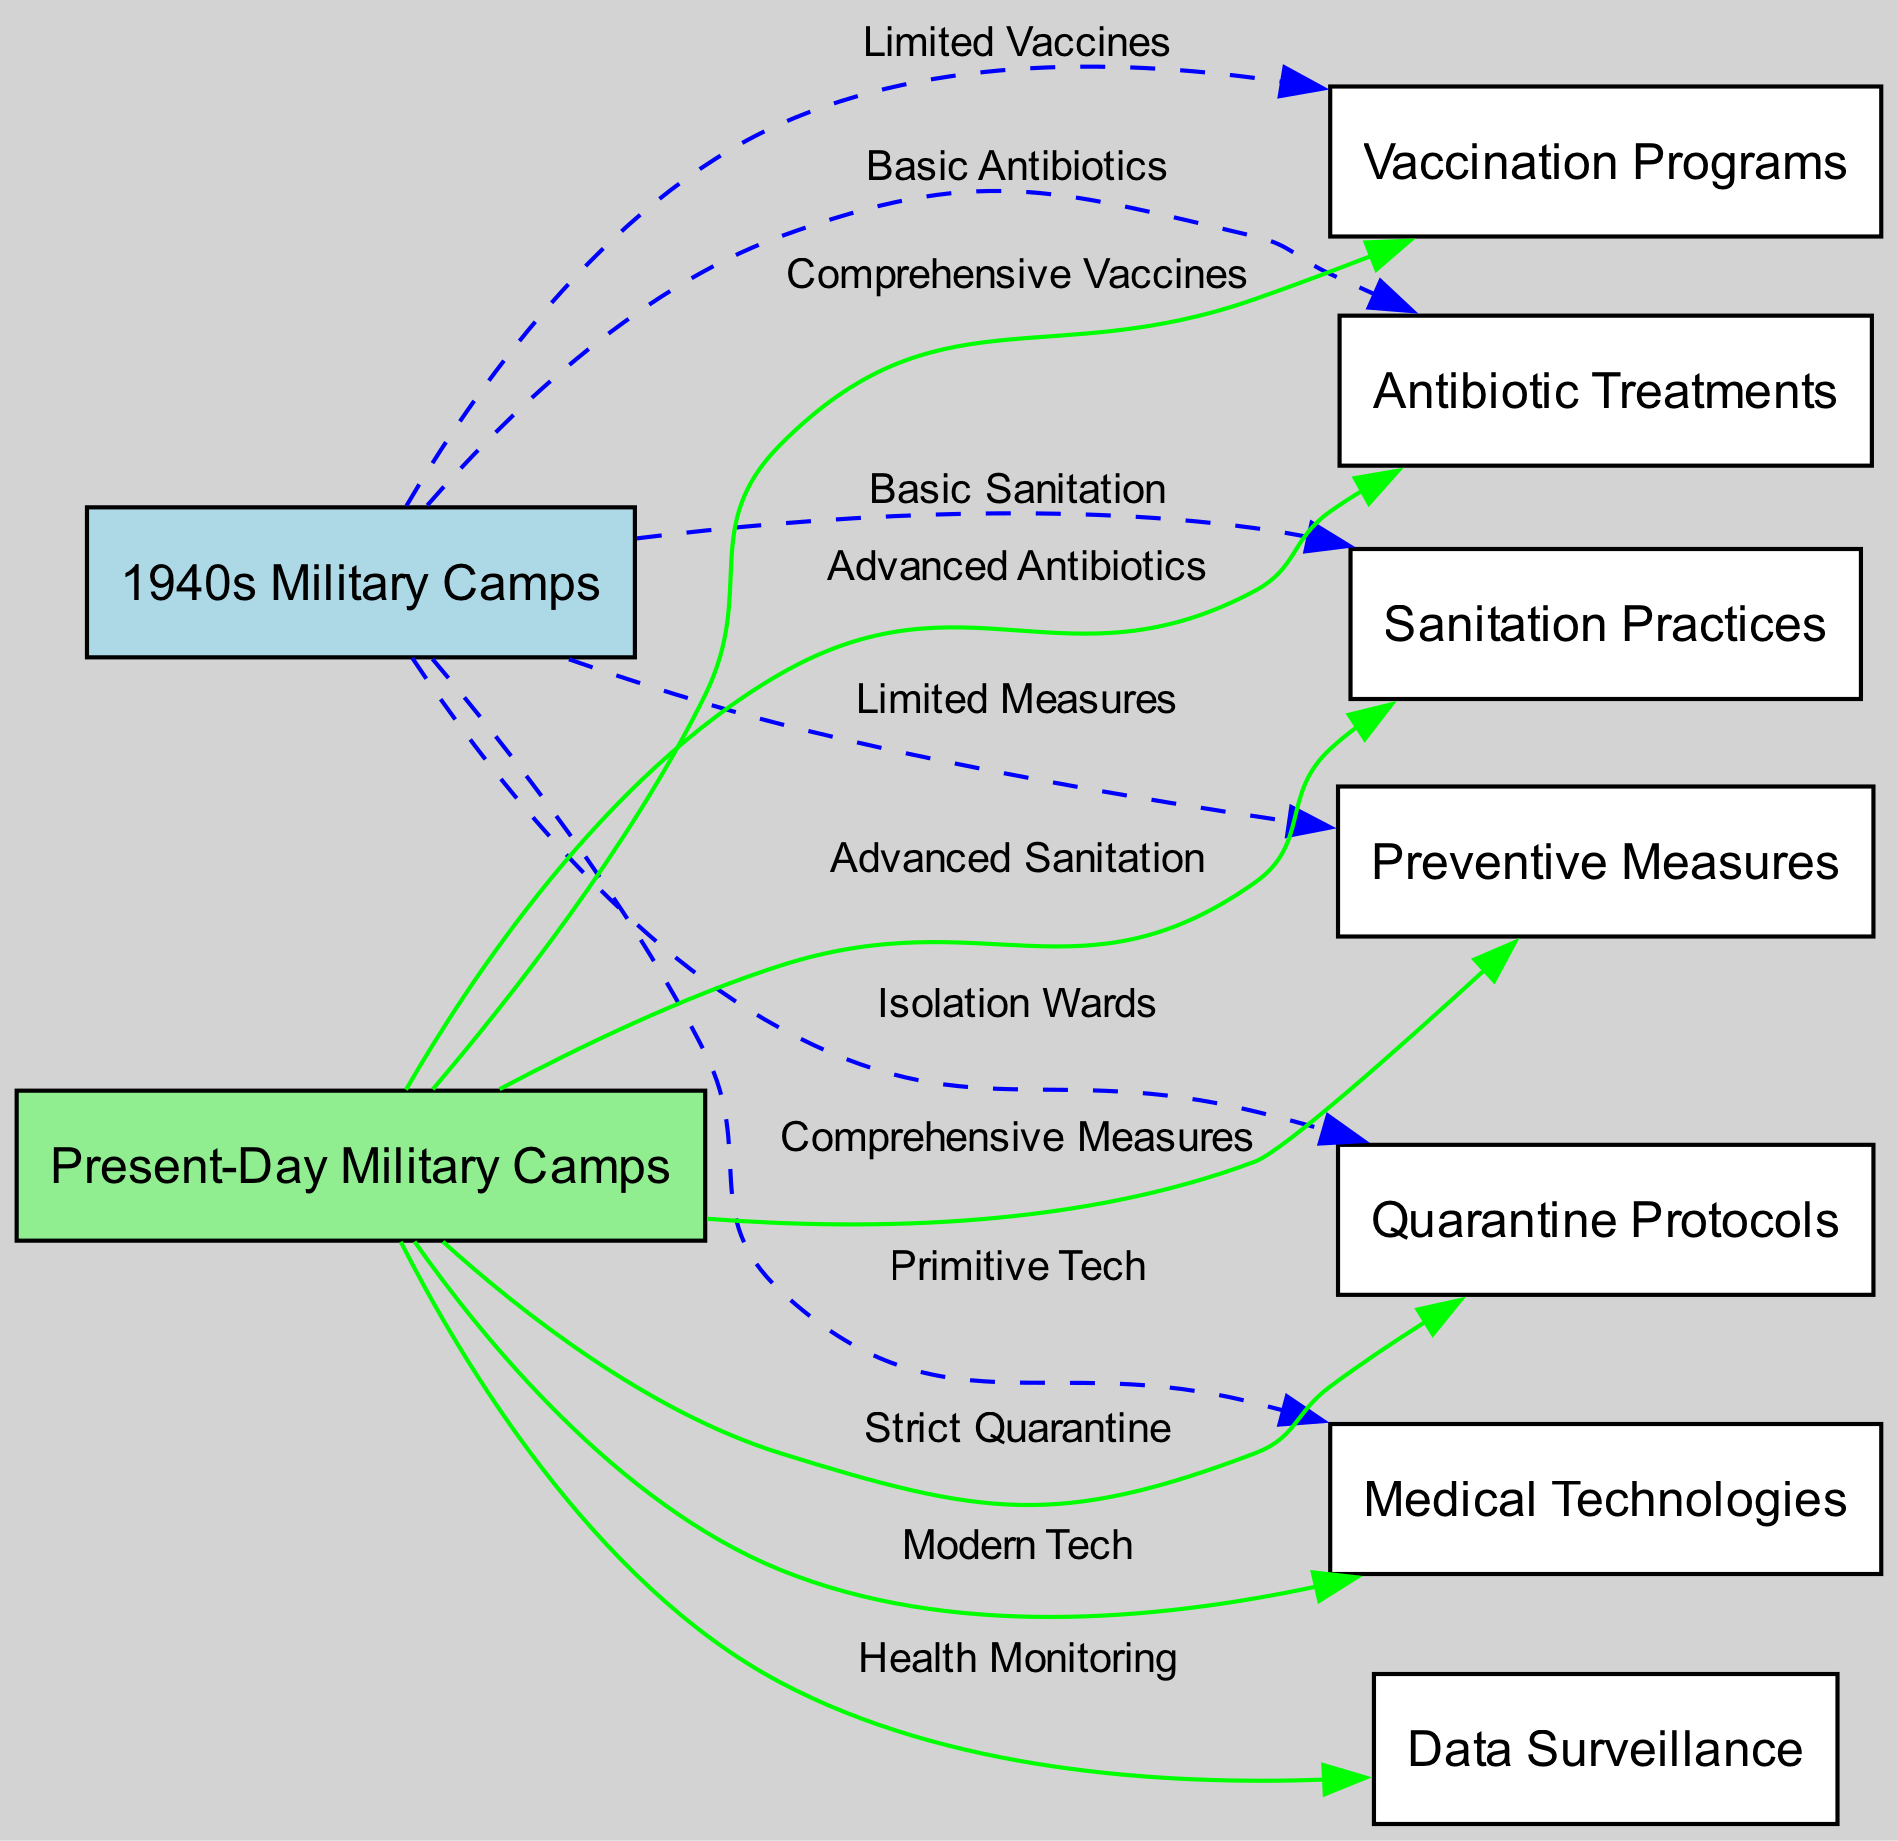What is the label for the edge connecting 1940s Military Camps and Sanitation Practices? The diagram shows that the label for the edge connecting these two nodes is "Basic Sanitation".
Answer: Basic Sanitation How many nodes are present in the diagram? The diagram consists of a total of 9 nodes, which include both the military camp eras and the various control measures.
Answer: 9 What technology advancement is represented in the transition from 1940s Military Camps to Present-Day Military Camps regarding medical technologies? The diagram indicates that the 1940s Military Camps utilized "Primitive Tech", while the Present-Day Military Camps use "Modern Tech".
Answer: Modern Tech What type of quarantine protocols were used in 1940s Military Camps? According to the diagram, the quarantine protocols in the 1940s Military Camps were labeled as "Isolation Wards".
Answer: Isolation Wards Which preventive measure category shows a clear distinction between military camps from the 1940s and present day? The preventive measures differ significantly, with the 1940s Military Camps having "Limited Measures" compared to the "Comprehensive Measures" employed in present-day camps.
Answer: Comprehensive Measures What does the edge label from Present-Day Military Camps to Data Surveillance signify? The edge label indicates that the connection represents "Health Monitoring", demonstrating a focus on data management and surveillance in the present context.
Answer: Health Monitoring What kind of antibiotic treatments were available in the 1940s Military Camps? The diagram specifies that the antibiotic treatments available during the 1940s were termed "Basic Antibiotics".
Answer: Basic Antibiotics Which two nodes connect to Present-Day Military Camps? The edges indicate that Present-Day Military Camps connect to several nodes, prominently including "Sanitation Practices" and "Quarantine Protocols".
Answer: Sanitation Practices, Quarantine Protocols How has the approach to vaccination programs changed from the 1940s to present day? The diagram highlights this change, illustrating the move from "Limited Vaccines" in the 1940s to "Comprehensive Vaccines" in present-day military camps.
Answer: Comprehensive Vaccines 